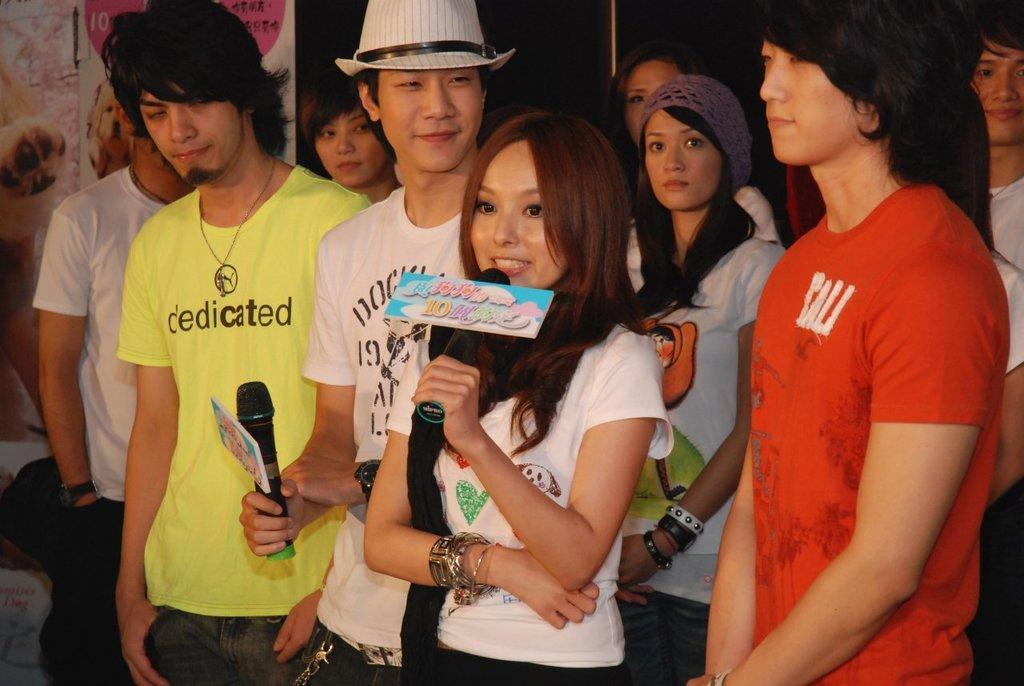How would you summarize this image in a sentence or two? In this image I can see few persons standing. Two persons are holding mic in their hands. One person is wearing a hat. 